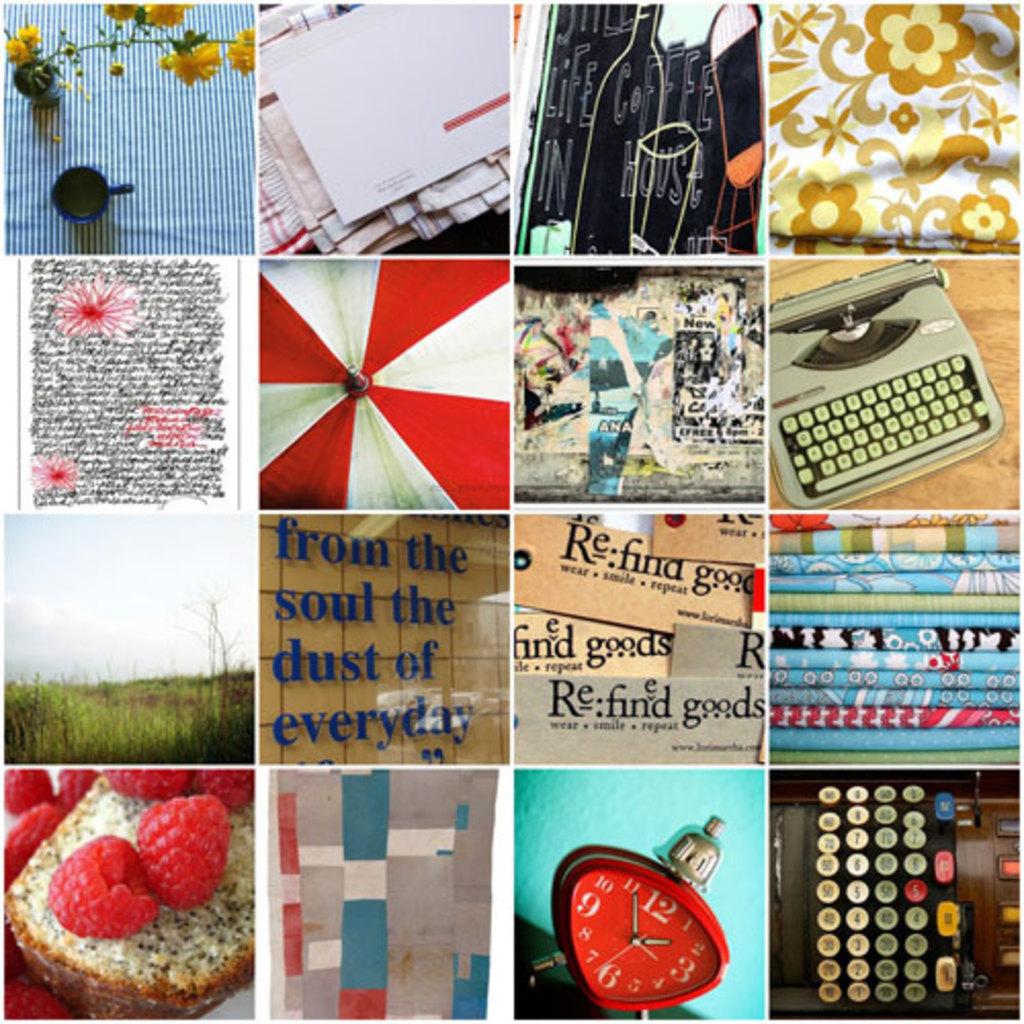What time is on the clock?
Offer a very short reply. 1:55. 